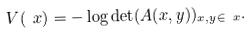<formula> <loc_0><loc_0><loc_500><loc_500>V ( \ x ) = - \log \det ( A ( x , y ) ) _ { x , y \in \ x } .</formula> 